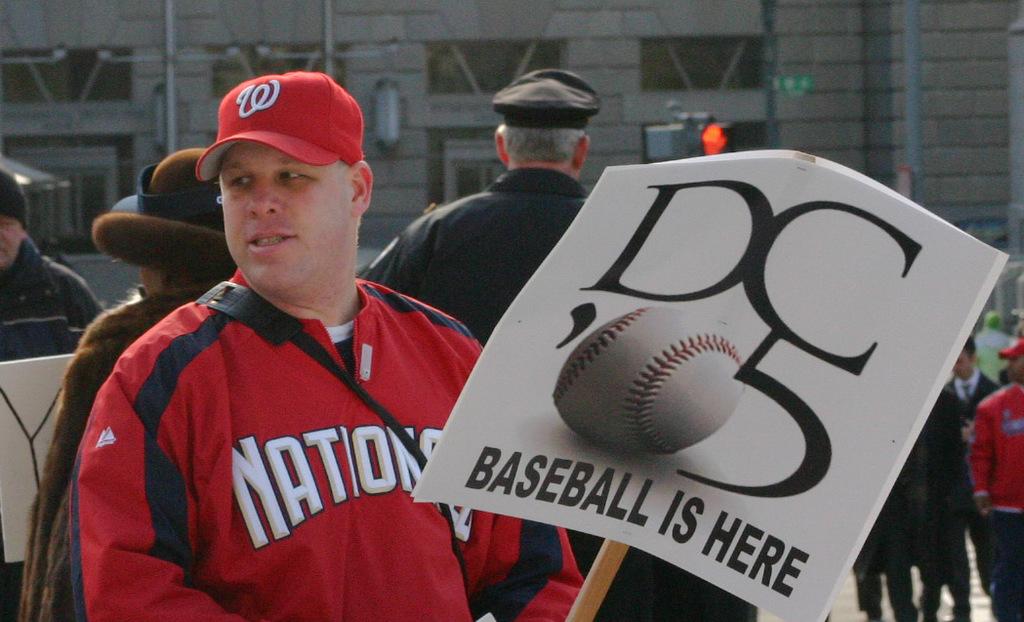What sport is this man attending according to his sign?
Ensure brevity in your answer.  Baseball. What is the team on his jacket?
Your answer should be very brief. Nations. 